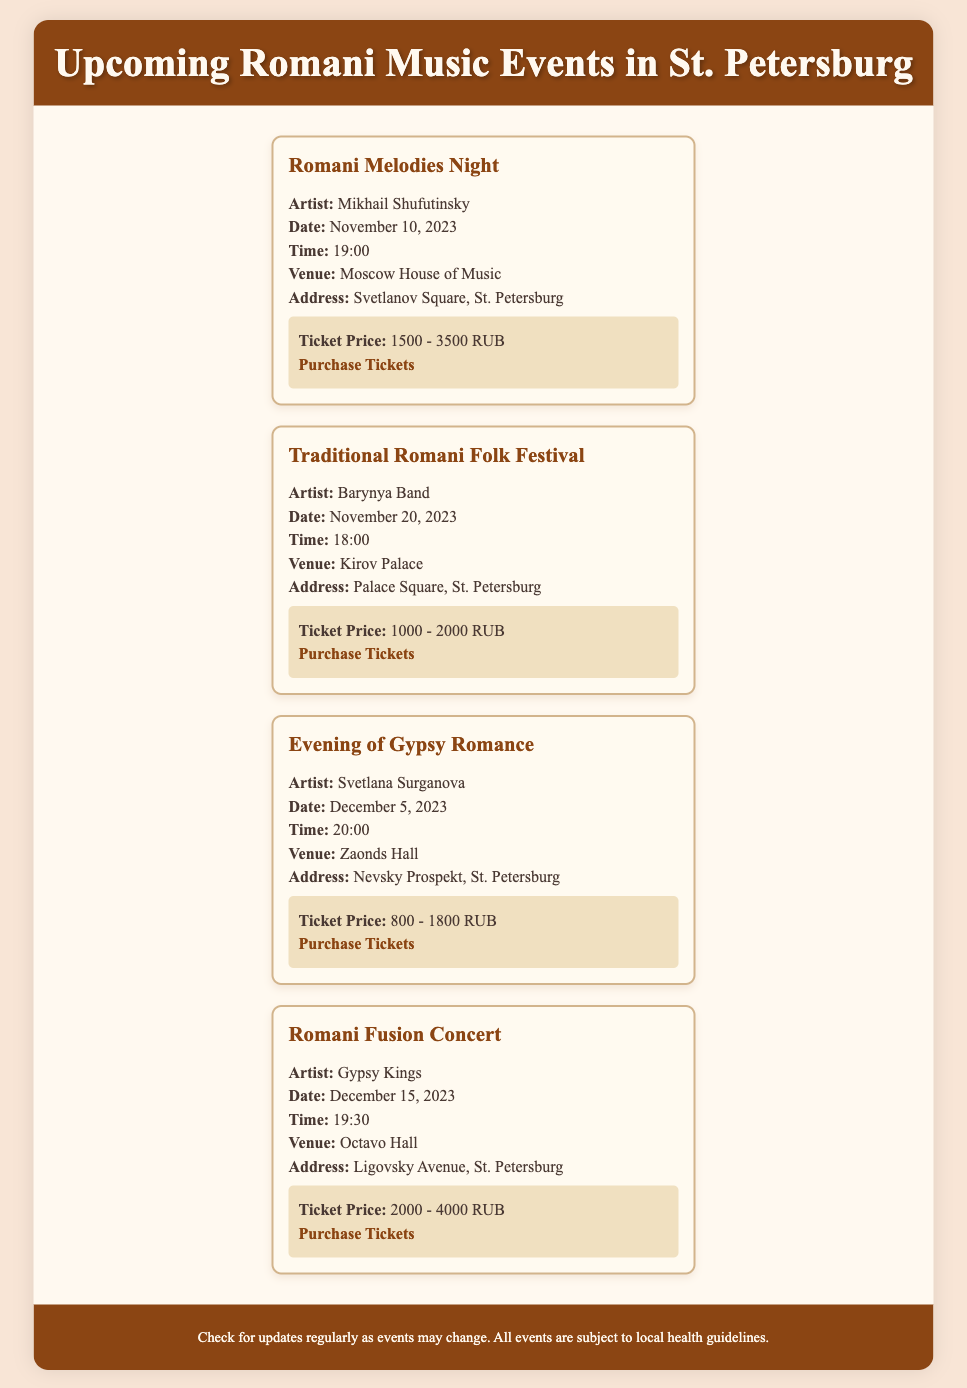What is the first event listed? The first event in the list is "Romani Melodies Night."
Answer: Romani Melodies Night Who is performing at the Traditional Romani Folk Festival? The artist performing at this festival is the Barynya Band.
Answer: Barynya Band What is the ticket price range for the Evening of Gypsy Romance? The ticket price range for this event is mentioned as 800 - 1800 RUB.
Answer: 800 - 1800 RUB When is the Romani Fusion Concert scheduled? The Romani Fusion Concert is scheduled for December 15, 2023.
Answer: December 15, 2023 Which venue hosts the event on November 10, 2023? The event on this date will be hosted at the Moscow House of Music.
Answer: Moscow House of Music What time does the Romani Melodies Night start? The starting time for Romani Melodies Night is 19:00.
Answer: 19:00 What is the address of the Kirov Palace? The address of the Kirov Palace is Palace Square, St. Petersburg.
Answer: Palace Square, St. Petersburg How many events are scheduled in December? There are two events scheduled in December.
Answer: Two Which artist is performing last in the schedule? The last artist in the schedule is Gypsy Kings.
Answer: Gypsy Kings 